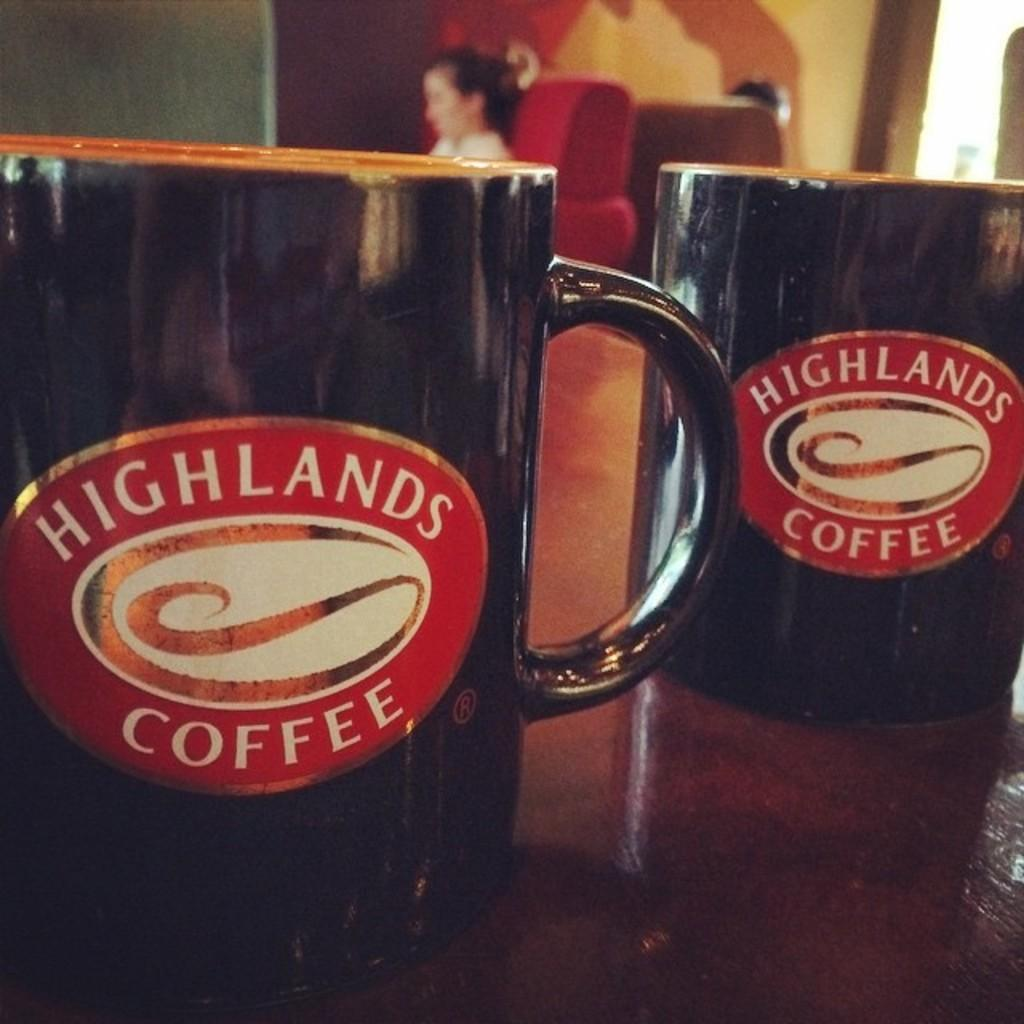<image>
Share a concise interpretation of the image provided. two coffee cups with highlands coffee logo on them and on a wooden surface and a female in the background 